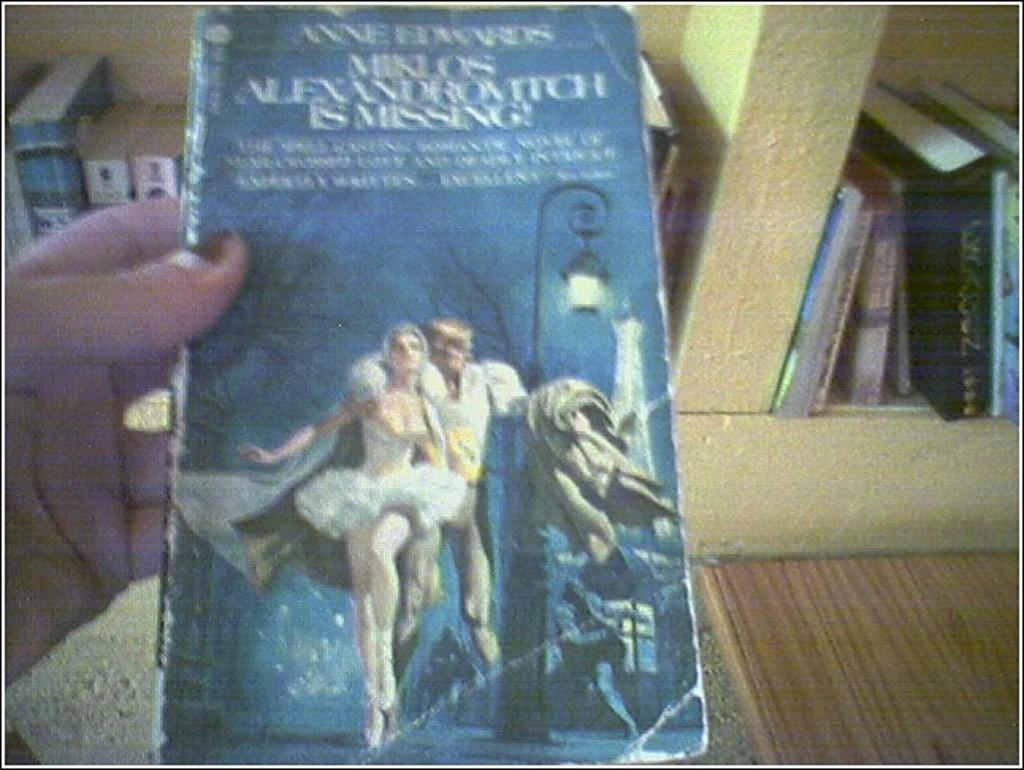<image>
Write a terse but informative summary of the picture. A book that is by a author named Anne Edwards. 